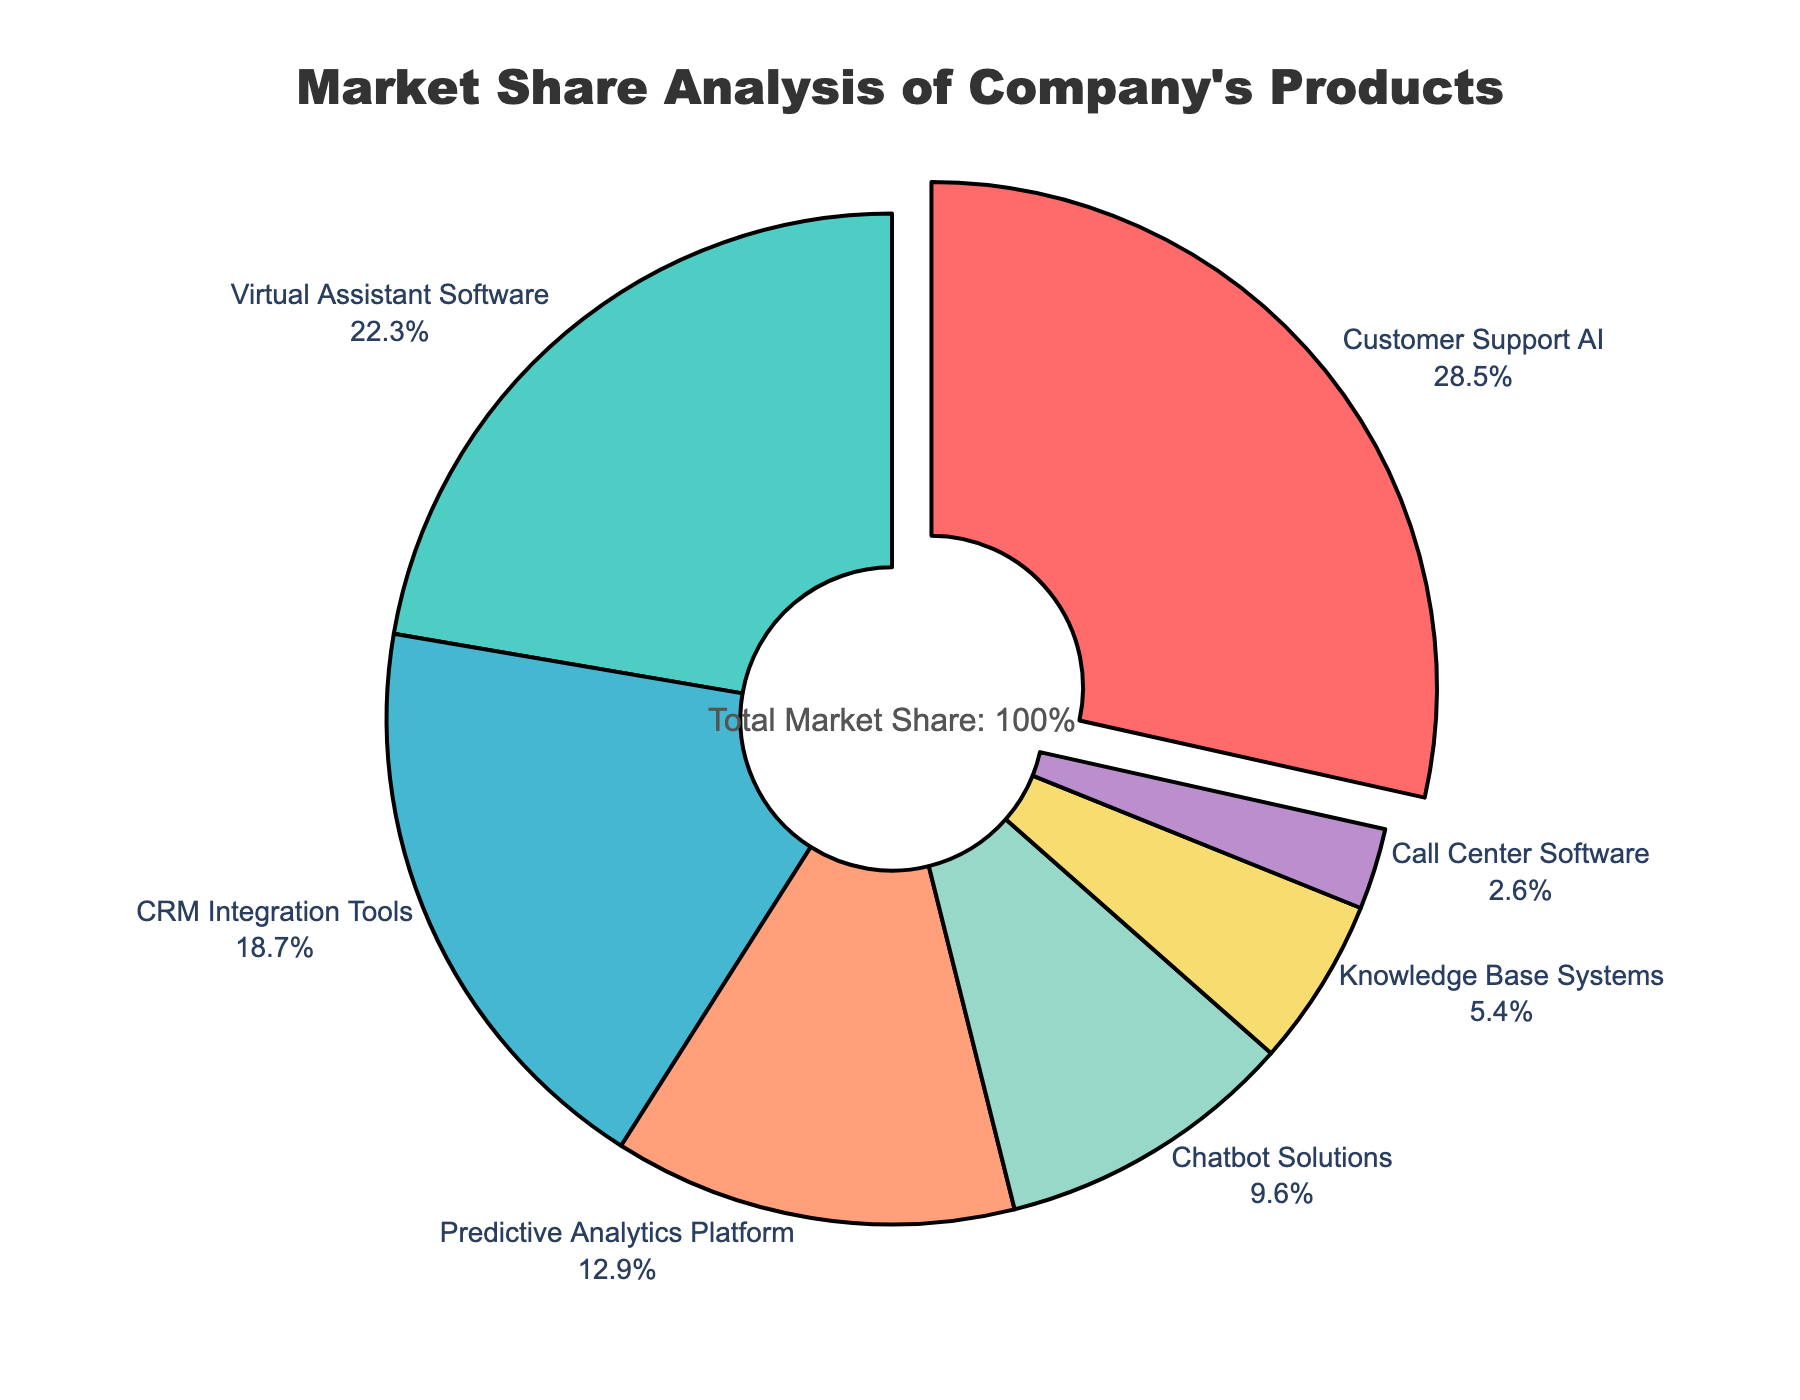Which product has the largest market share? The figure shows that Customer Support AI has the largest slice of the pie chart, representing 28.5% of the market share.
Answer: Customer Support AI Which product has a market share that is closest to 10%? The pie chart shows the market shares of various products, and Chatbot Solutions has a market share of 9.6%, which is closest to 10%.
Answer: Chatbot Solutions What is the combined market share of Virtual Assistant Software and CRM Integration Tools? Virtual Assistant Software has a market share of 22.3%, and CRM Integration Tools has a market share of 18.7%. Adding these together gives 22.3% + 18.7% = 41%.
Answer: 41% Which product has the smallest market share, and what is its value? The pie chart indicates that Call Center Software has the smallest slice, representing a market share of 2.6%.
Answer: Call Center Software, 2.6% How much larger is the market share of Customer Support AI compared to that of Knowledge Base Systems? Customer Support AI has a market share of 28.5%, and Knowledge Base Systems have 5.4%. The difference is 28.5% - 5.4% = 23.1%.
Answer: 23.1% What is the total market share of all products except Customer Support AI? Subtract the market share of Customer Support AI (28.5%) from 100%. 100% - 28.5% = 71.5%.
Answer: 71.5% Which two products together make up roughly half of the total market share? Adding the market shares of Customer Support AI (28.5%) and Virtual Assistant Software (22.3%) gives 28.5% + 22.3% = 50.8%, which is roughly half.
Answer: Customer Support AI and Virtual Assistant Software Compare the market share of Predictive Analytics Platform to Chatbot Solutions. Which is higher, and by how much? Predictive Analytics Platform has a market share of 12.9%, and Chatbot Solutions have 9.6%. The difference is 12.9% - 9.6% = 3.3%. Predictive Analytics Platform is higher by 3.3%.
Answer: Predictive Analytics Platform, 3.3% What fraction of the total market share is held by CRM Integration Tools and Predictive Analytics Platform combined? Adding the market shares of CRM Integration Tools (18.7%) and Predictive Analytics Platform (12.9%) gives 18.7% + 12.9% = 31.6%. In fraction terms, 31.6% is 31.6/100 or simplified to 316/1000.
Answer: 31.6% What's the sum of the market shares of the two smallest segments? Call Center Software (2.6%) and Knowledge Base Systems (5.4%) are the smallest segments. Adding these gives 2.6% + 5.4% = 8%.
Answer: 8% 